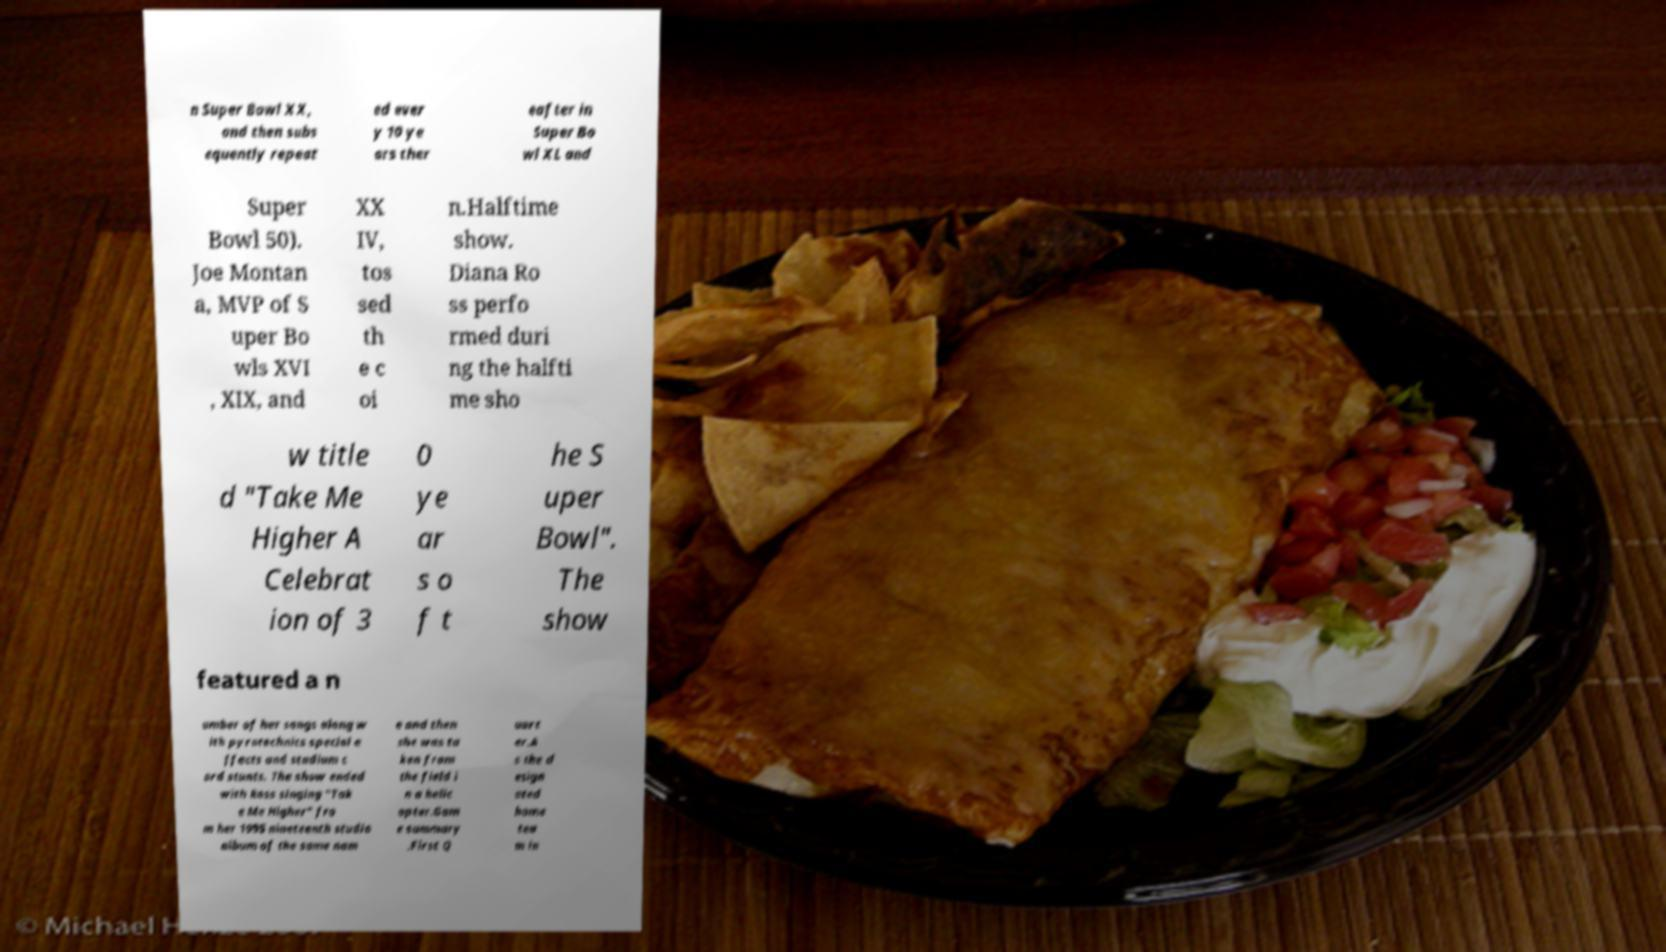Can you read and provide the text displayed in the image?This photo seems to have some interesting text. Can you extract and type it out for me? n Super Bowl XX, and then subs equently repeat ed ever y 10 ye ars ther eafter in Super Bo wl XL and Super Bowl 50). Joe Montan a, MVP of S uper Bo wls XVI , XIX, and XX IV, tos sed th e c oi n.Halftime show. Diana Ro ss perfo rmed duri ng the halfti me sho w title d "Take Me Higher A Celebrat ion of 3 0 ye ar s o f t he S uper Bowl". The show featured a n umber of her songs along w ith pyrotechnics special e ffects and stadium c ard stunts. The show ended with Ross singing "Tak e Me Higher" fro m her 1995 nineteenth studio album of the same nam e and then she was ta ken from the field i n a helic opter.Gam e summary .First Q uart er.A s the d esign ated home tea m in 